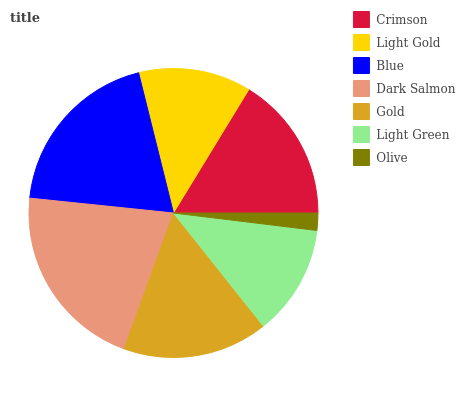Is Olive the minimum?
Answer yes or no. Yes. Is Dark Salmon the maximum?
Answer yes or no. Yes. Is Light Gold the minimum?
Answer yes or no. No. Is Light Gold the maximum?
Answer yes or no. No. Is Crimson greater than Light Gold?
Answer yes or no. Yes. Is Light Gold less than Crimson?
Answer yes or no. Yes. Is Light Gold greater than Crimson?
Answer yes or no. No. Is Crimson less than Light Gold?
Answer yes or no. No. Is Gold the high median?
Answer yes or no. Yes. Is Gold the low median?
Answer yes or no. Yes. Is Olive the high median?
Answer yes or no. No. Is Light Green the low median?
Answer yes or no. No. 